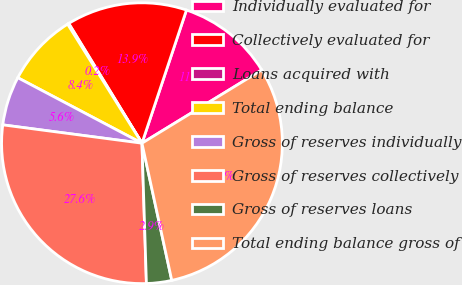Convert chart. <chart><loc_0><loc_0><loc_500><loc_500><pie_chart><fcel>Individually evaluated for<fcel>Collectively evaluated for<fcel>Loans acquired with<fcel>Total ending balance<fcel>Gross of reserves individually<fcel>Gross of reserves collectively<fcel>Gross of reserves loans<fcel>Total ending balance gross of<nl><fcel>11.13%<fcel>13.87%<fcel>0.15%<fcel>8.39%<fcel>5.64%<fcel>27.59%<fcel>2.9%<fcel>30.33%<nl></chart> 